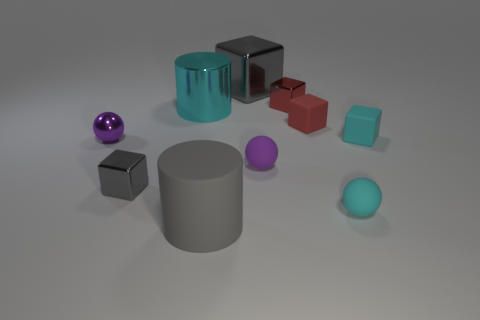Is the size of the gray cylinder the same as the purple sphere that is on the left side of the cyan cylinder?
Offer a terse response. No. Is the number of large metallic blocks behind the big metallic cube less than the number of purple rubber balls?
Your response must be concise. Yes. How many small rubber blocks are the same color as the large cube?
Provide a short and direct response. 0. Is the number of small objects less than the number of large cyan things?
Offer a very short reply. No. Is the material of the tiny gray object the same as the big cyan cylinder?
Offer a very short reply. Yes. How many other objects are the same size as the cyan cube?
Offer a very short reply. 6. There is a tiny metallic thing in front of the small purple metal ball in front of the tiny red shiny thing; what color is it?
Provide a short and direct response. Gray. What number of other objects are the same shape as the purple metallic object?
Your answer should be very brief. 2. Is there a red cube made of the same material as the big gray cube?
Provide a short and direct response. Yes. What material is the cyan thing that is the same size as the gray matte cylinder?
Offer a terse response. Metal. 